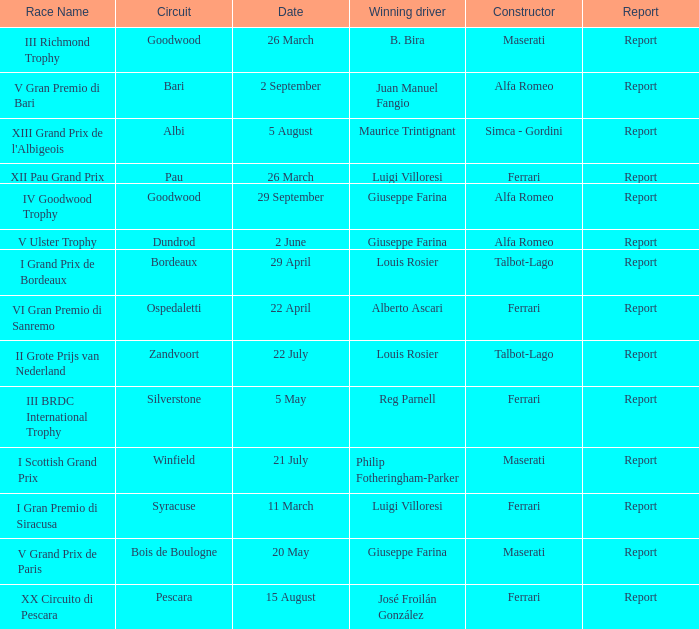Name the report for philip fotheringham-parker Report. 